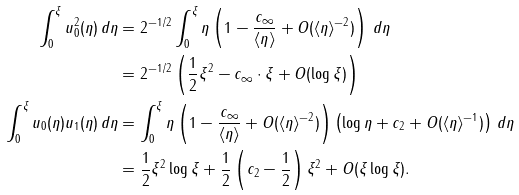Convert formula to latex. <formula><loc_0><loc_0><loc_500><loc_500>\int _ { 0 } ^ { \xi } u _ { 0 } ^ { 2 } ( \eta ) \, d \eta & = 2 ^ { - 1 / 2 } \int _ { 0 } ^ { \xi } \eta \left ( 1 - \frac { c _ { \infty } } { \langle \eta \rangle } + O ( \langle \eta \rangle ^ { - 2 } ) \right ) \, d \eta \\ & = 2 ^ { - 1 / 2 } \left ( \frac { 1 } { 2 } \xi ^ { 2 } - c _ { \infty } \cdot \xi + O ( \log \xi ) \right ) \\ \int _ { 0 } ^ { \xi } u _ { 0 } ( \eta ) u _ { 1 } ( \eta ) \, d \eta & = \int _ { 0 } ^ { \xi } \eta \left ( 1 - \frac { c _ { \infty } } { \langle \eta \rangle } + O ( \langle \eta \rangle ^ { - 2 } ) \right ) \left ( \log \eta + c _ { 2 } + O ( \langle \eta \rangle ^ { - 1 } ) \right ) \, d \eta \\ & = \frac { 1 } { 2 } \xi ^ { 2 } \log \xi + \frac { 1 } { 2 } \left ( c _ { 2 } - \frac { 1 } { 2 } \right ) \xi ^ { 2 } + O ( \xi \log \xi ) .</formula> 